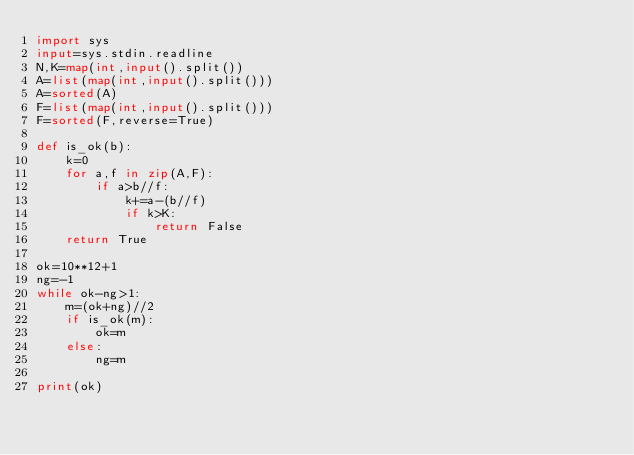<code> <loc_0><loc_0><loc_500><loc_500><_Python_>import sys
input=sys.stdin.readline
N,K=map(int,input().split())
A=list(map(int,input().split()))
A=sorted(A)
F=list(map(int,input().split()))
F=sorted(F,reverse=True)

def is_ok(b):
    k=0
    for a,f in zip(A,F):
        if a>b//f:
            k+=a-(b//f)
            if k>K:
                return False
    return True

ok=10**12+1
ng=-1
while ok-ng>1:
    m=(ok+ng)//2
    if is_ok(m):
        ok=m
    else:
        ng=m

print(ok)
</code> 